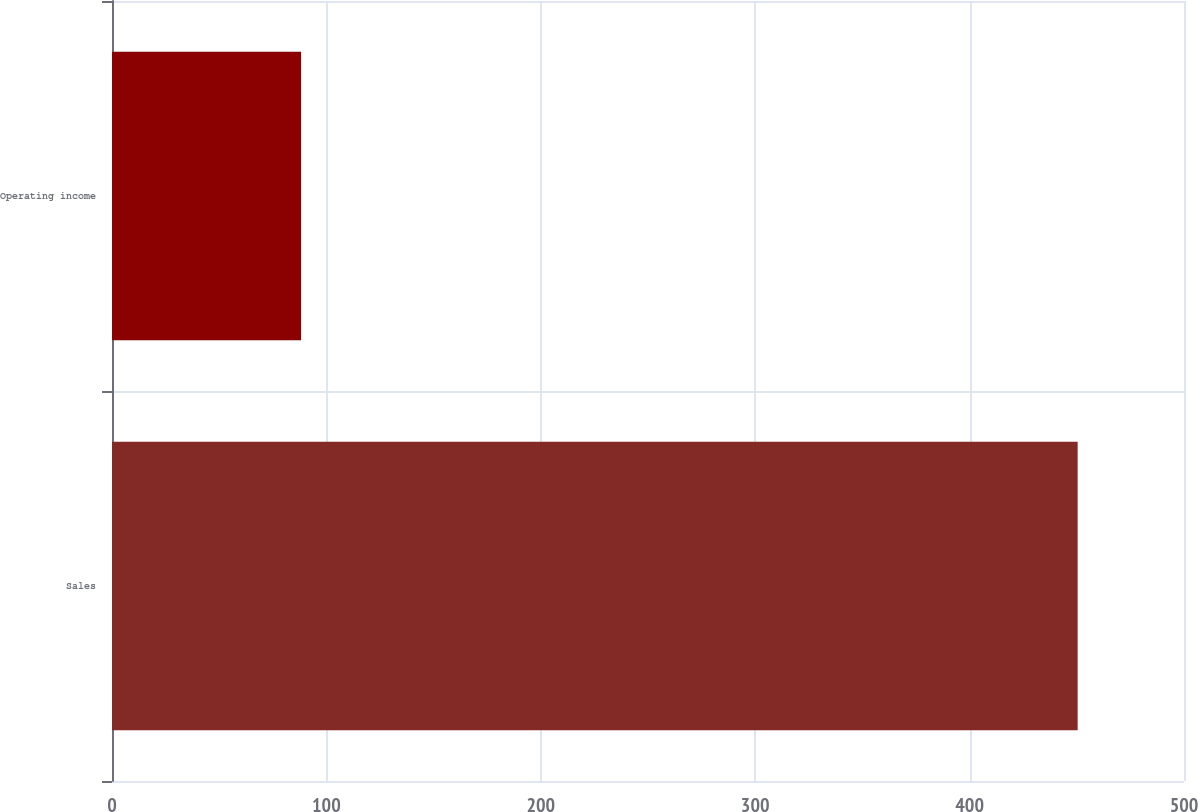Convert chart. <chart><loc_0><loc_0><loc_500><loc_500><bar_chart><fcel>Sales<fcel>Operating income<nl><fcel>450.4<fcel>88.2<nl></chart> 